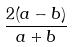Convert formula to latex. <formula><loc_0><loc_0><loc_500><loc_500>\frac { 2 ( a - b ) } { a + b }</formula> 